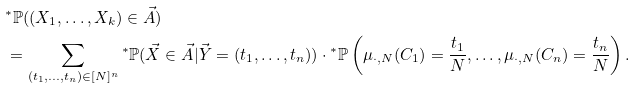Convert formula to latex. <formula><loc_0><loc_0><loc_500><loc_500>& { ^ { * } } \mathbb { P } ( ( X _ { 1 } , \dots , X _ { k } ) \in \vec { A } ) \\ & = \sum _ { ( t _ { 1 } , \dots , t _ { n } ) \in [ N ] ^ { n } } { ^ { * } } \mathbb { P } ( \vec { X } \in \vec { A } | \vec { Y } = ( t _ { 1 } , \dots , t _ { n } ) ) \cdot { ^ { * } } \mathbb { P } \left ( \mu _ { \cdot , N } ( C _ { 1 } ) = \frac { t _ { 1 } } { N } , \dots , \mu _ { \cdot , N } ( C _ { n } ) = \frac { t _ { n } } { N } \right ) .</formula> 